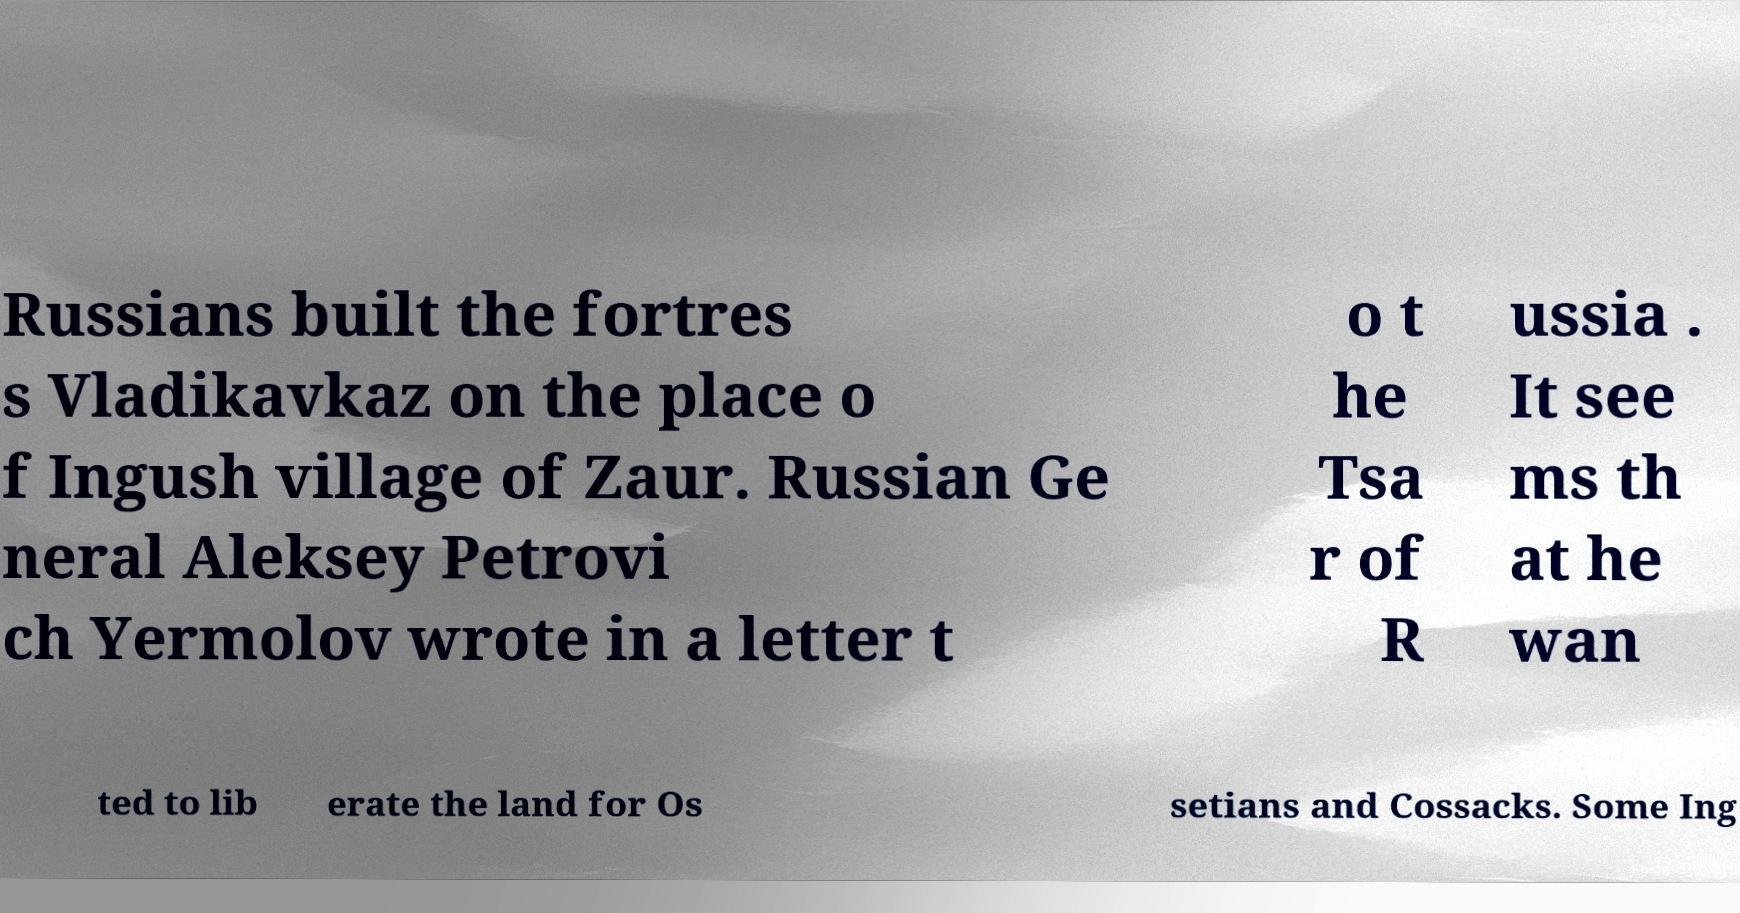Can you read and provide the text displayed in the image?This photo seems to have some interesting text. Can you extract and type it out for me? Russians built the fortres s Vladikavkaz on the place o f Ingush village of Zaur. Russian Ge neral Aleksey Petrovi ch Yermolov wrote in a letter t o t he Tsa r of R ussia . It see ms th at he wan ted to lib erate the land for Os setians and Cossacks. Some Ing 